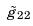Convert formula to latex. <formula><loc_0><loc_0><loc_500><loc_500>\tilde { g } _ { 2 2 }</formula> 